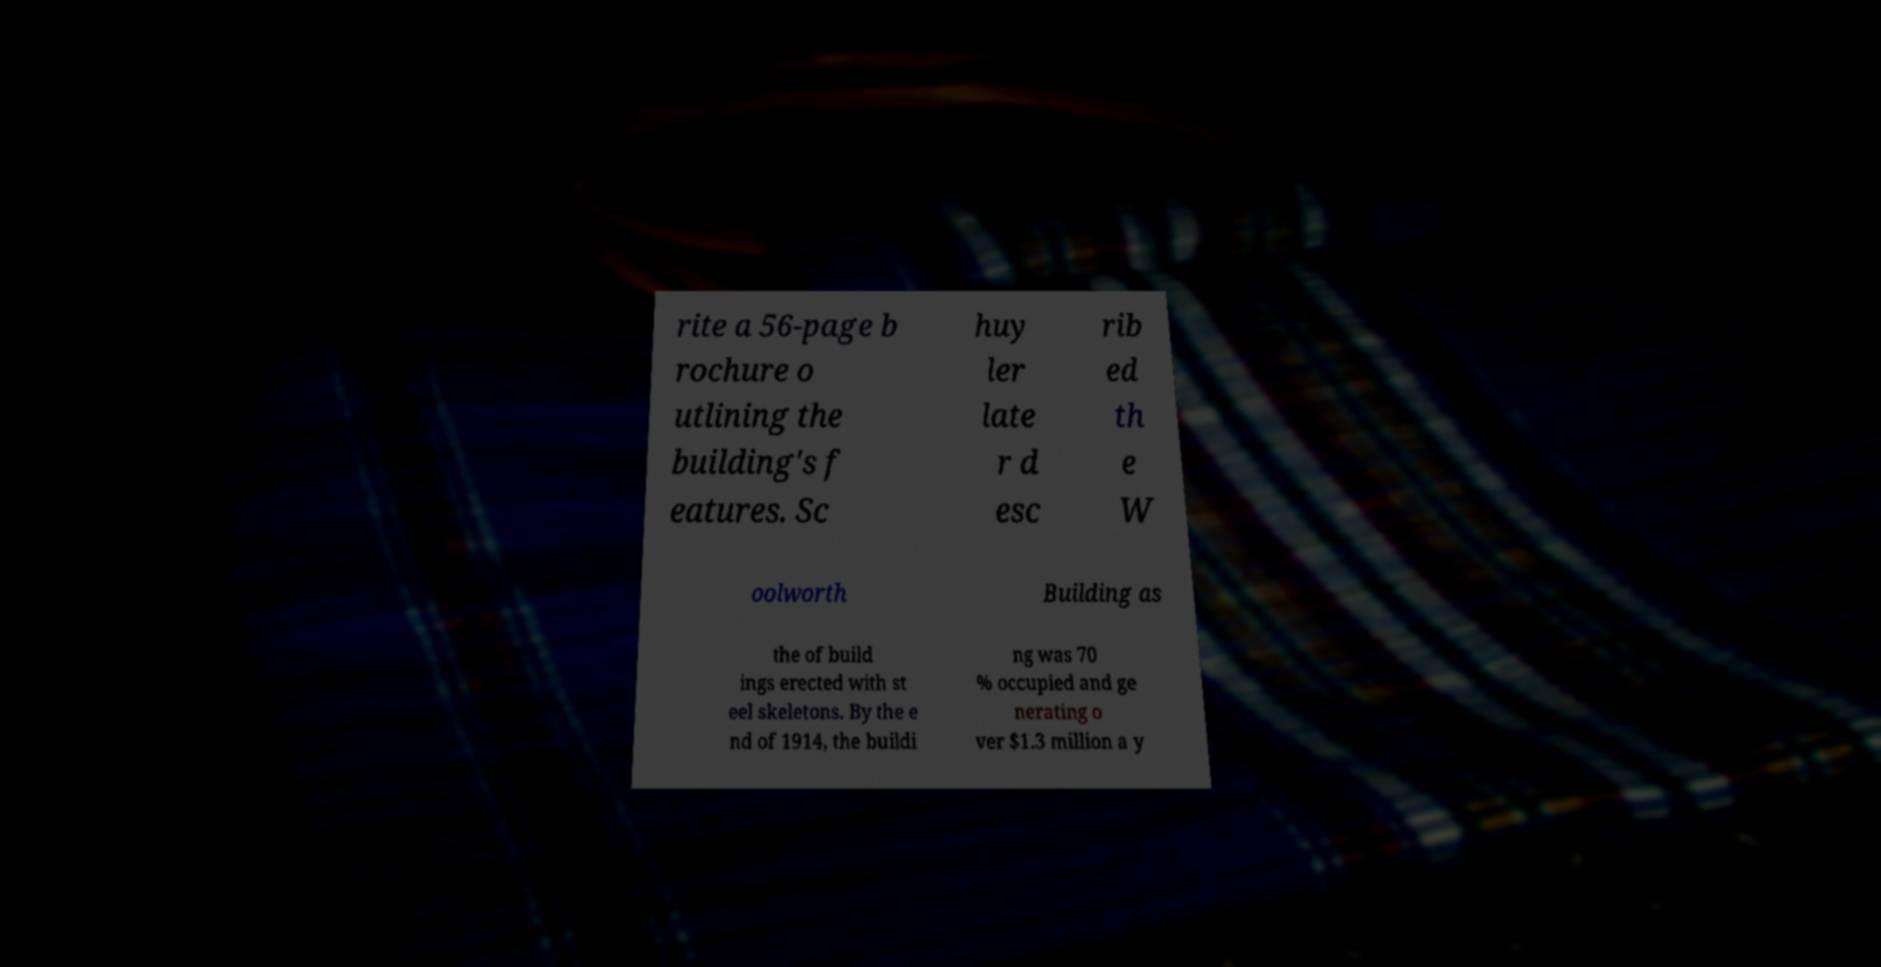For documentation purposes, I need the text within this image transcribed. Could you provide that? rite a 56-page b rochure o utlining the building's f eatures. Sc huy ler late r d esc rib ed th e W oolworth Building as the of build ings erected with st eel skeletons. By the e nd of 1914, the buildi ng was 70 % occupied and ge nerating o ver $1.3 million a y 